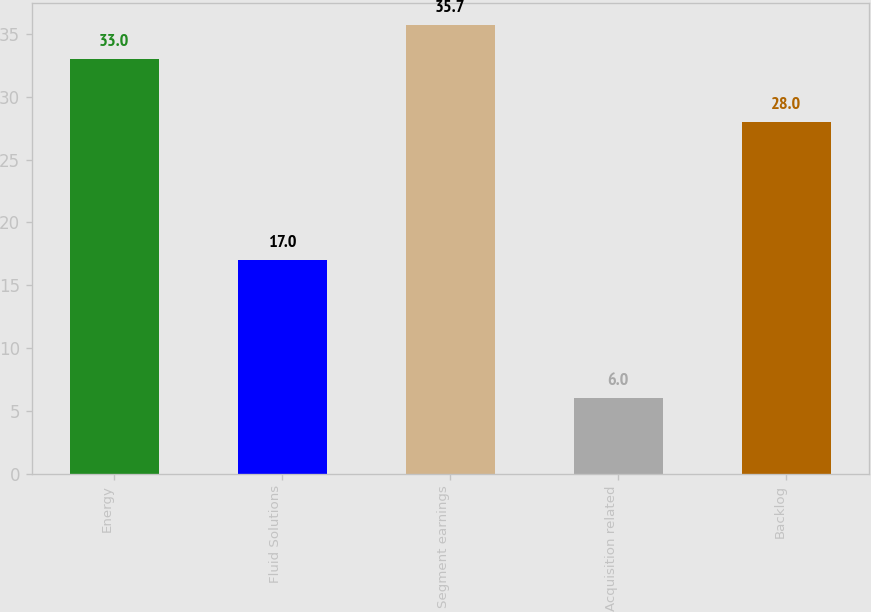<chart> <loc_0><loc_0><loc_500><loc_500><bar_chart><fcel>Energy<fcel>Fluid Solutions<fcel>Segment earnings<fcel>Acquisition related<fcel>Backlog<nl><fcel>33<fcel>17<fcel>35.7<fcel>6<fcel>28<nl></chart> 